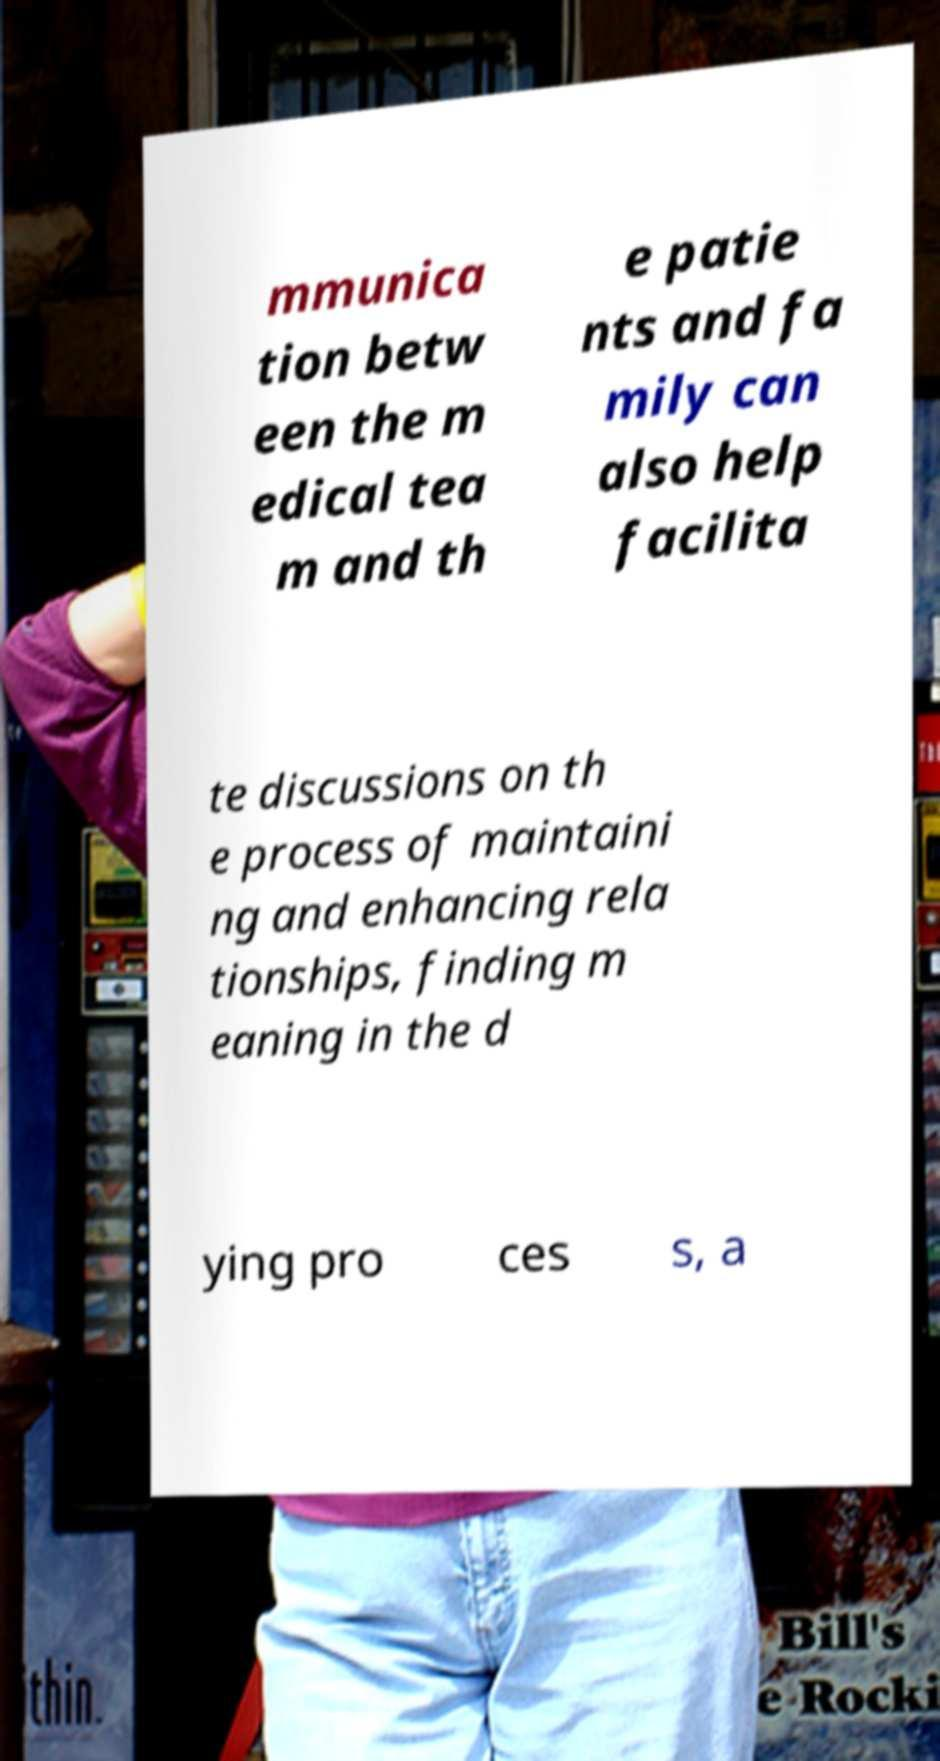Please identify and transcribe the text found in this image. mmunica tion betw een the m edical tea m and th e patie nts and fa mily can also help facilita te discussions on th e process of maintaini ng and enhancing rela tionships, finding m eaning in the d ying pro ces s, a 